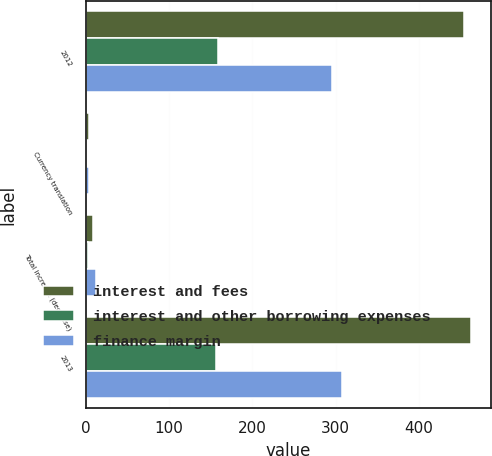Convert chart. <chart><loc_0><loc_0><loc_500><loc_500><stacked_bar_chart><ecel><fcel>2012<fcel>Currency translation<fcel>Total increase (decrease)<fcel>2013<nl><fcel>interest and fees<fcel>453.7<fcel>3.9<fcel>9.1<fcel>462.8<nl><fcel>interest and other borrowing expenses<fcel>158.4<fcel>0.1<fcel>2.5<fcel>155.9<nl><fcel>finance margin<fcel>295.3<fcel>4<fcel>11.6<fcel>306.9<nl></chart> 